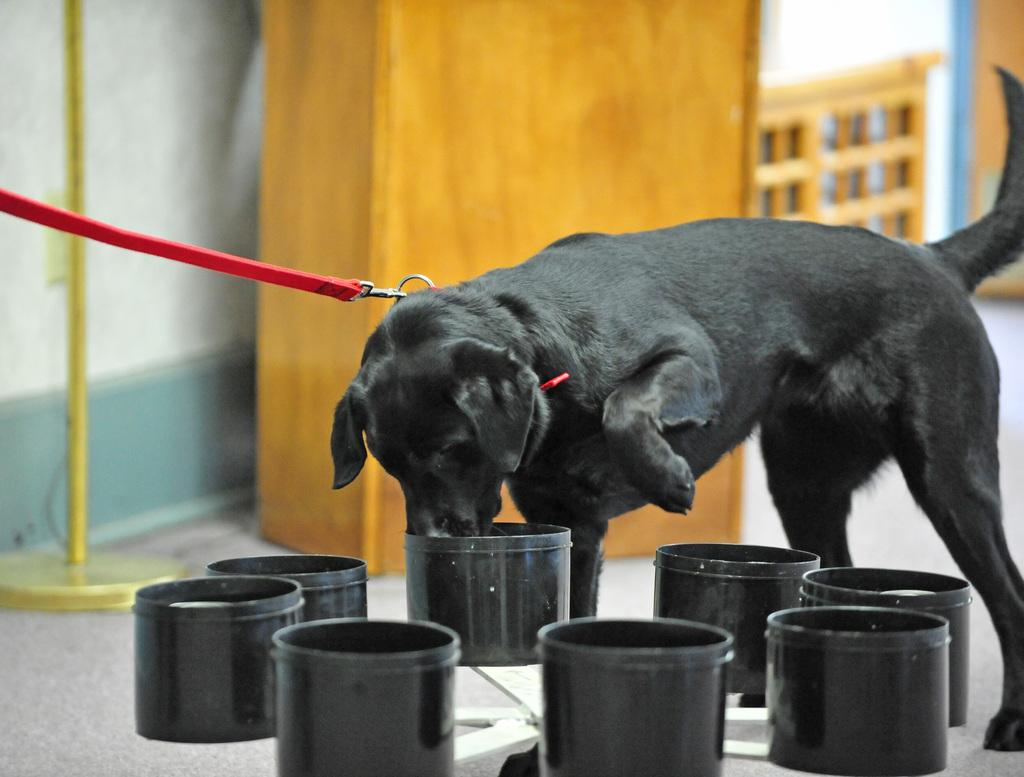What animal can be seen in the image? There is a dog in the image. How is the dog restrained in the image? The dog is tied with a leash. What objects are present in the image for the dog's use? There are bowls in the image. What type of material is the object the dog is tied to? There is a wooden object in the image. What structure is present in the image for supporting the dog's belongings? There is a stand in the image. What type of background can be seen in the image? There is a wall in the image. How many spiders are crawling on the dog in the image? There are no spiders present in the image; it only features a dog tied with a leash and other objects. What type of fowl can be seen interacting with the dog in the image? There is no fowl present in the image; it only features a dog tied with a leash and other objects. 